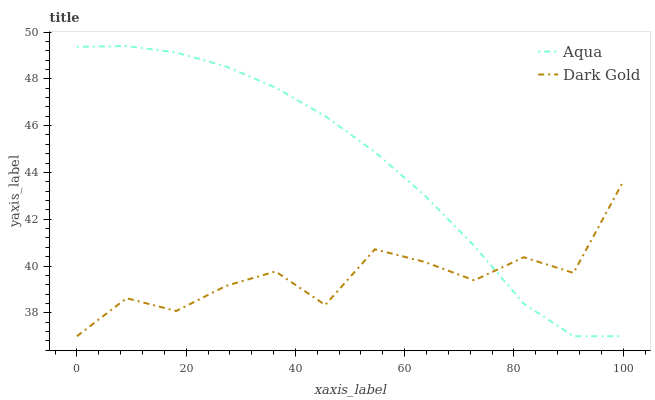Does Dark Gold have the maximum area under the curve?
Answer yes or no. No. Is Dark Gold the smoothest?
Answer yes or no. No. Does Dark Gold have the highest value?
Answer yes or no. No. 